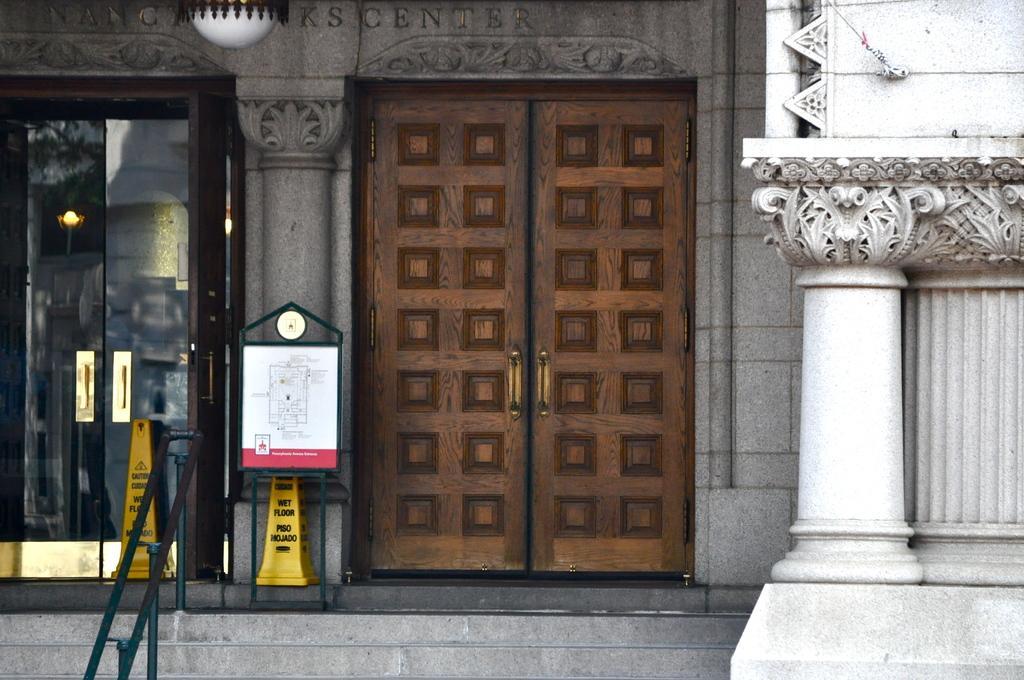Can you describe this image briefly? In this image I can see steps, doors, light, pillars and a building wall. This image is taken may be during a day. 